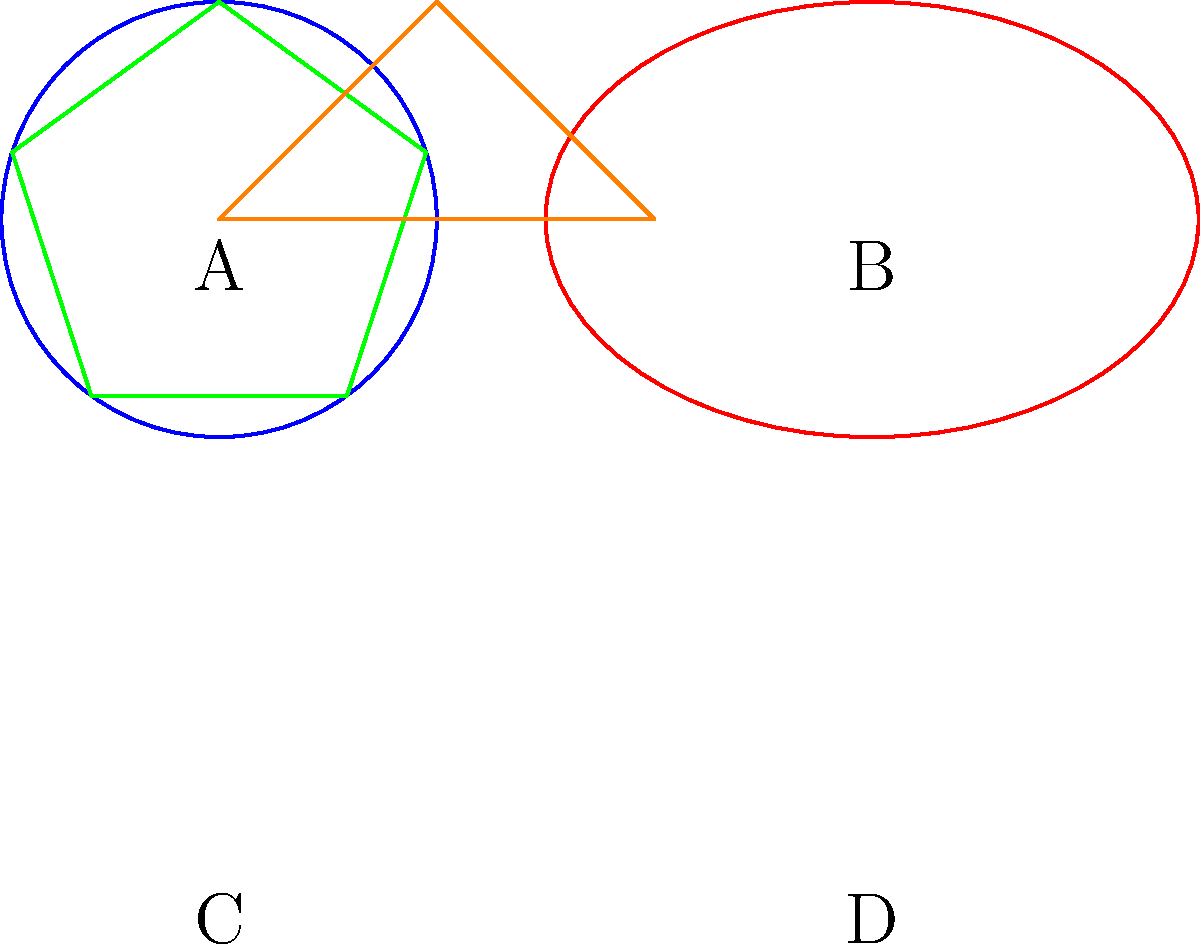In the context of abstract art and copyright disputes, which pair of shapes shown above are homeomorphic, potentially raising questions about originality? To determine which shapes are homeomorphic, we need to consider the topological properties of each shape:

1. Shape A is a circle.
2. Shape B is an ellipse.
3. Shape C is a pentagon.
4. Shape D is a triangle.

Homeomorphic shapes are those that can be continuously deformed into one another without cutting or gluing. In topological terms, they have the same fundamental structure.

Step 1: Compare the number of holes in each shape.
- Shapes A and B both have one hole (the interior region).
- Shapes C and D have no holes.

Step 2: Consider the continuity of the shapes.
- All shapes are closed curves without any cuts or breaks.

Step 3: Analyze the deformability between shapes.
- A circle (A) can be continuously stretched into an ellipse (B) without breaking the curve.
- A pentagon (C) cannot be deformed into a triangle (D) without breaking and rejoining edges.

Step 4: Conclusion
The pair of shapes that are homeomorphic are A (circle) and B (ellipse). This is because a circle can be continuously deformed into an ellipse without altering its topological properties.

In the context of copyright disputes in abstract art, this homeomorphism between A and B could potentially raise questions about originality if one artist claimed copyright infringement based on the use of a similar shape.
Answer: A and B (circle and ellipse) 